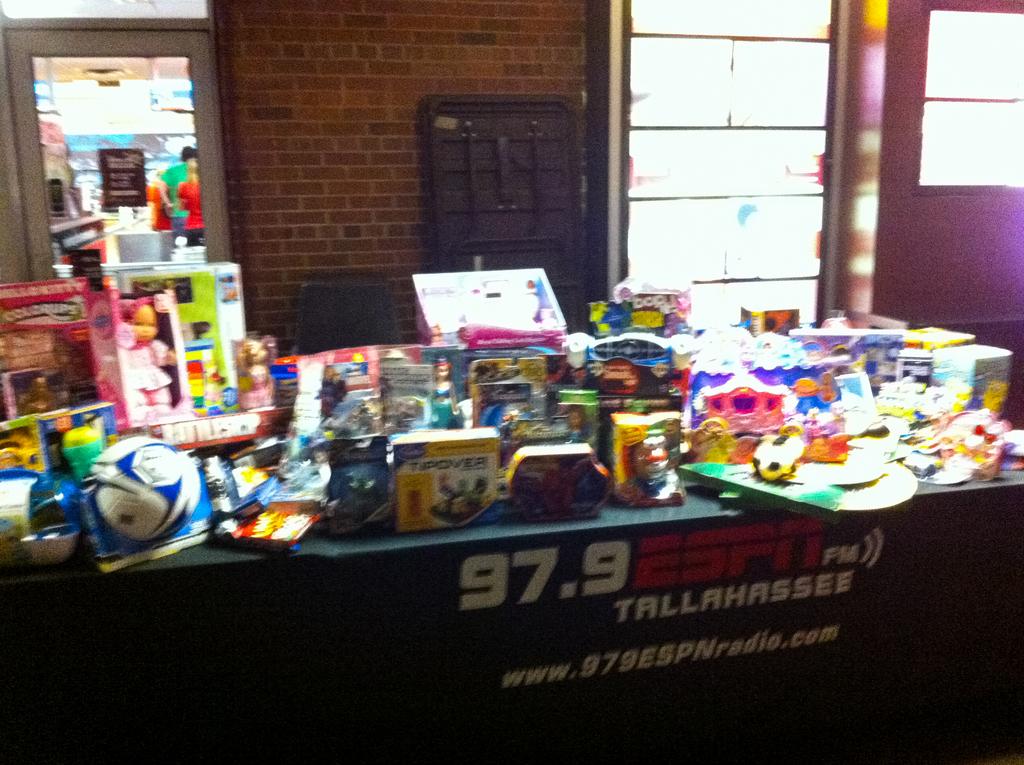Is that a studio?
Your response must be concise. Unanswerable. What radio station is being advertised on the banner?
Your answer should be very brief. 97.9. 